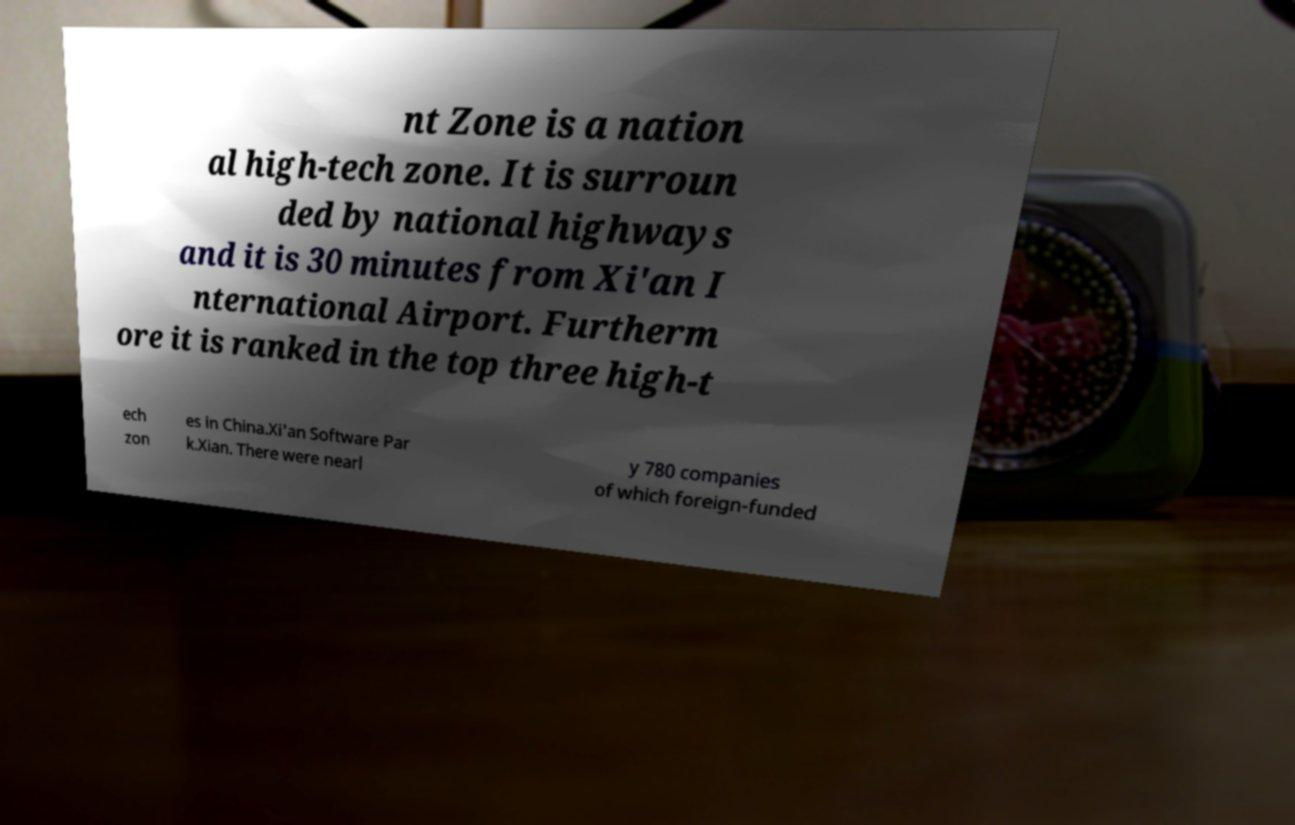Can you read and provide the text displayed in the image?This photo seems to have some interesting text. Can you extract and type it out for me? nt Zone is a nation al high-tech zone. It is surroun ded by national highways and it is 30 minutes from Xi'an I nternational Airport. Furtherm ore it is ranked in the top three high-t ech zon es in China.Xi'an Software Par k.Xian. There were nearl y 780 companies of which foreign-funded 